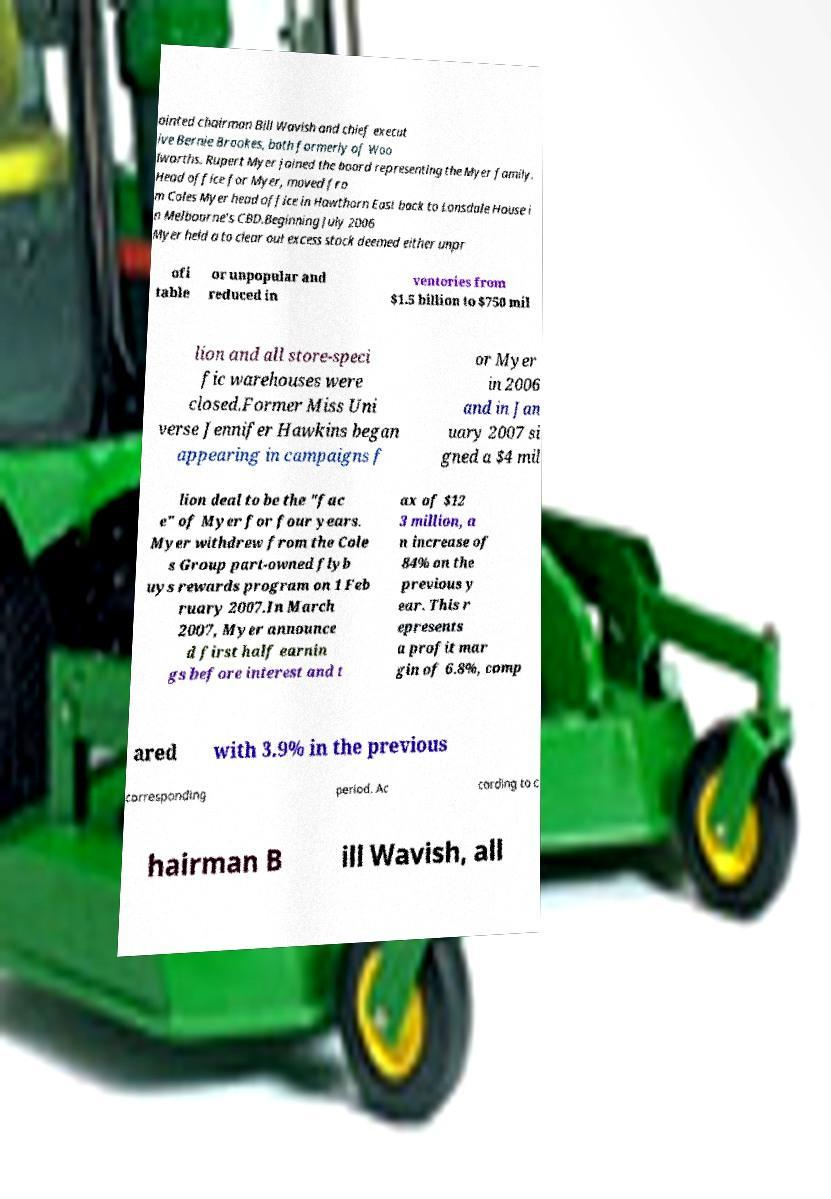Please read and relay the text visible in this image. What does it say? ointed chairman Bill Wavish and chief execut ive Bernie Brookes, both formerly of Woo lworths. Rupert Myer joined the board representing the Myer family. Head office for Myer, moved fro m Coles Myer head office in Hawthorn East back to Lonsdale House i n Melbourne's CBD.Beginning July 2006 Myer held a to clear out excess stock deemed either unpr ofi table or unpopular and reduced in ventories from $1.5 billion to $750 mil lion and all store-speci fic warehouses were closed.Former Miss Uni verse Jennifer Hawkins began appearing in campaigns f or Myer in 2006 and in Jan uary 2007 si gned a $4 mil lion deal to be the "fac e" of Myer for four years. Myer withdrew from the Cole s Group part-owned flyb uys rewards program on 1 Feb ruary 2007.In March 2007, Myer announce d first half earnin gs before interest and t ax of $12 3 million, a n increase of 84% on the previous y ear. This r epresents a profit mar gin of 6.8%, comp ared with 3.9% in the previous corresponding period. Ac cording to c hairman B ill Wavish, all 